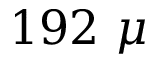<formula> <loc_0><loc_0><loc_500><loc_500>1 9 2 \mu</formula> 